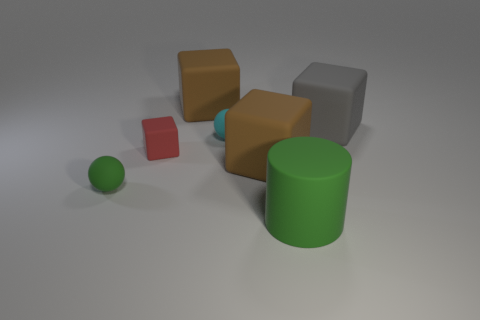The matte sphere that is the same color as the matte cylinder is what size?
Give a very brief answer. Small. Do the matte cylinder and the sphere that is on the left side of the red thing have the same color?
Offer a terse response. Yes. What number of objects are tiny matte things behind the green matte sphere or green cylinders?
Keep it short and to the point. 3. Is the number of matte spheres that are to the left of the tiny green rubber ball the same as the number of large cubes left of the gray matte cube?
Offer a terse response. No. The big brown cube that is to the right of the big object that is left of the big brown rubber thing that is in front of the tiny rubber cube is made of what material?
Your answer should be very brief. Rubber. How big is the block that is left of the cyan ball and right of the tiny red thing?
Ensure brevity in your answer.  Large. Do the big gray thing and the big green object have the same shape?
Provide a succinct answer. No. The large green object that is the same material as the small block is what shape?
Provide a short and direct response. Cylinder. How many tiny objects are gray metallic spheres or green rubber spheres?
Offer a very short reply. 1. There is a brown object that is in front of the gray object; are there any gray blocks in front of it?
Make the answer very short. No. 